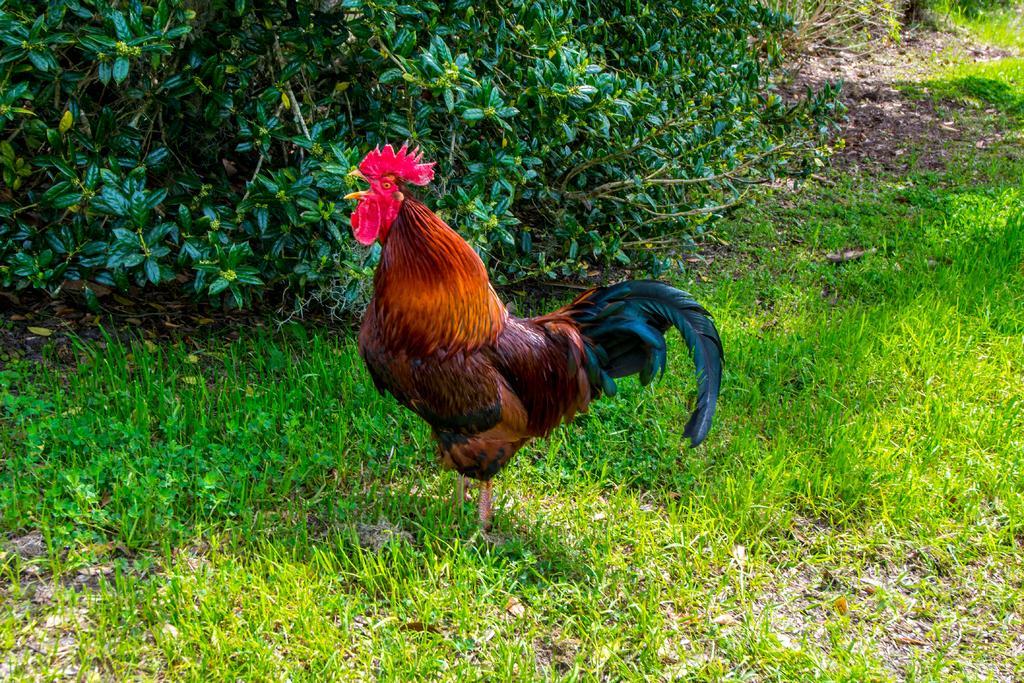Can you describe this image briefly? In the middle of the image we can see a roaster, and we can find grass and few plants. 